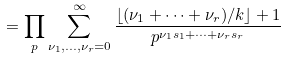<formula> <loc_0><loc_0><loc_500><loc_500>= \prod _ { p } \sum _ { \nu _ { 1 } , \dots , \nu _ { r } = 0 } ^ { \infty } \frac { \lfloor ( \nu _ { 1 } + \cdots + \nu _ { r } ) / k \rfloor + 1 } { p ^ { \nu _ { 1 } s _ { 1 } + \cdots + \nu _ { r } s _ { r } } }</formula> 